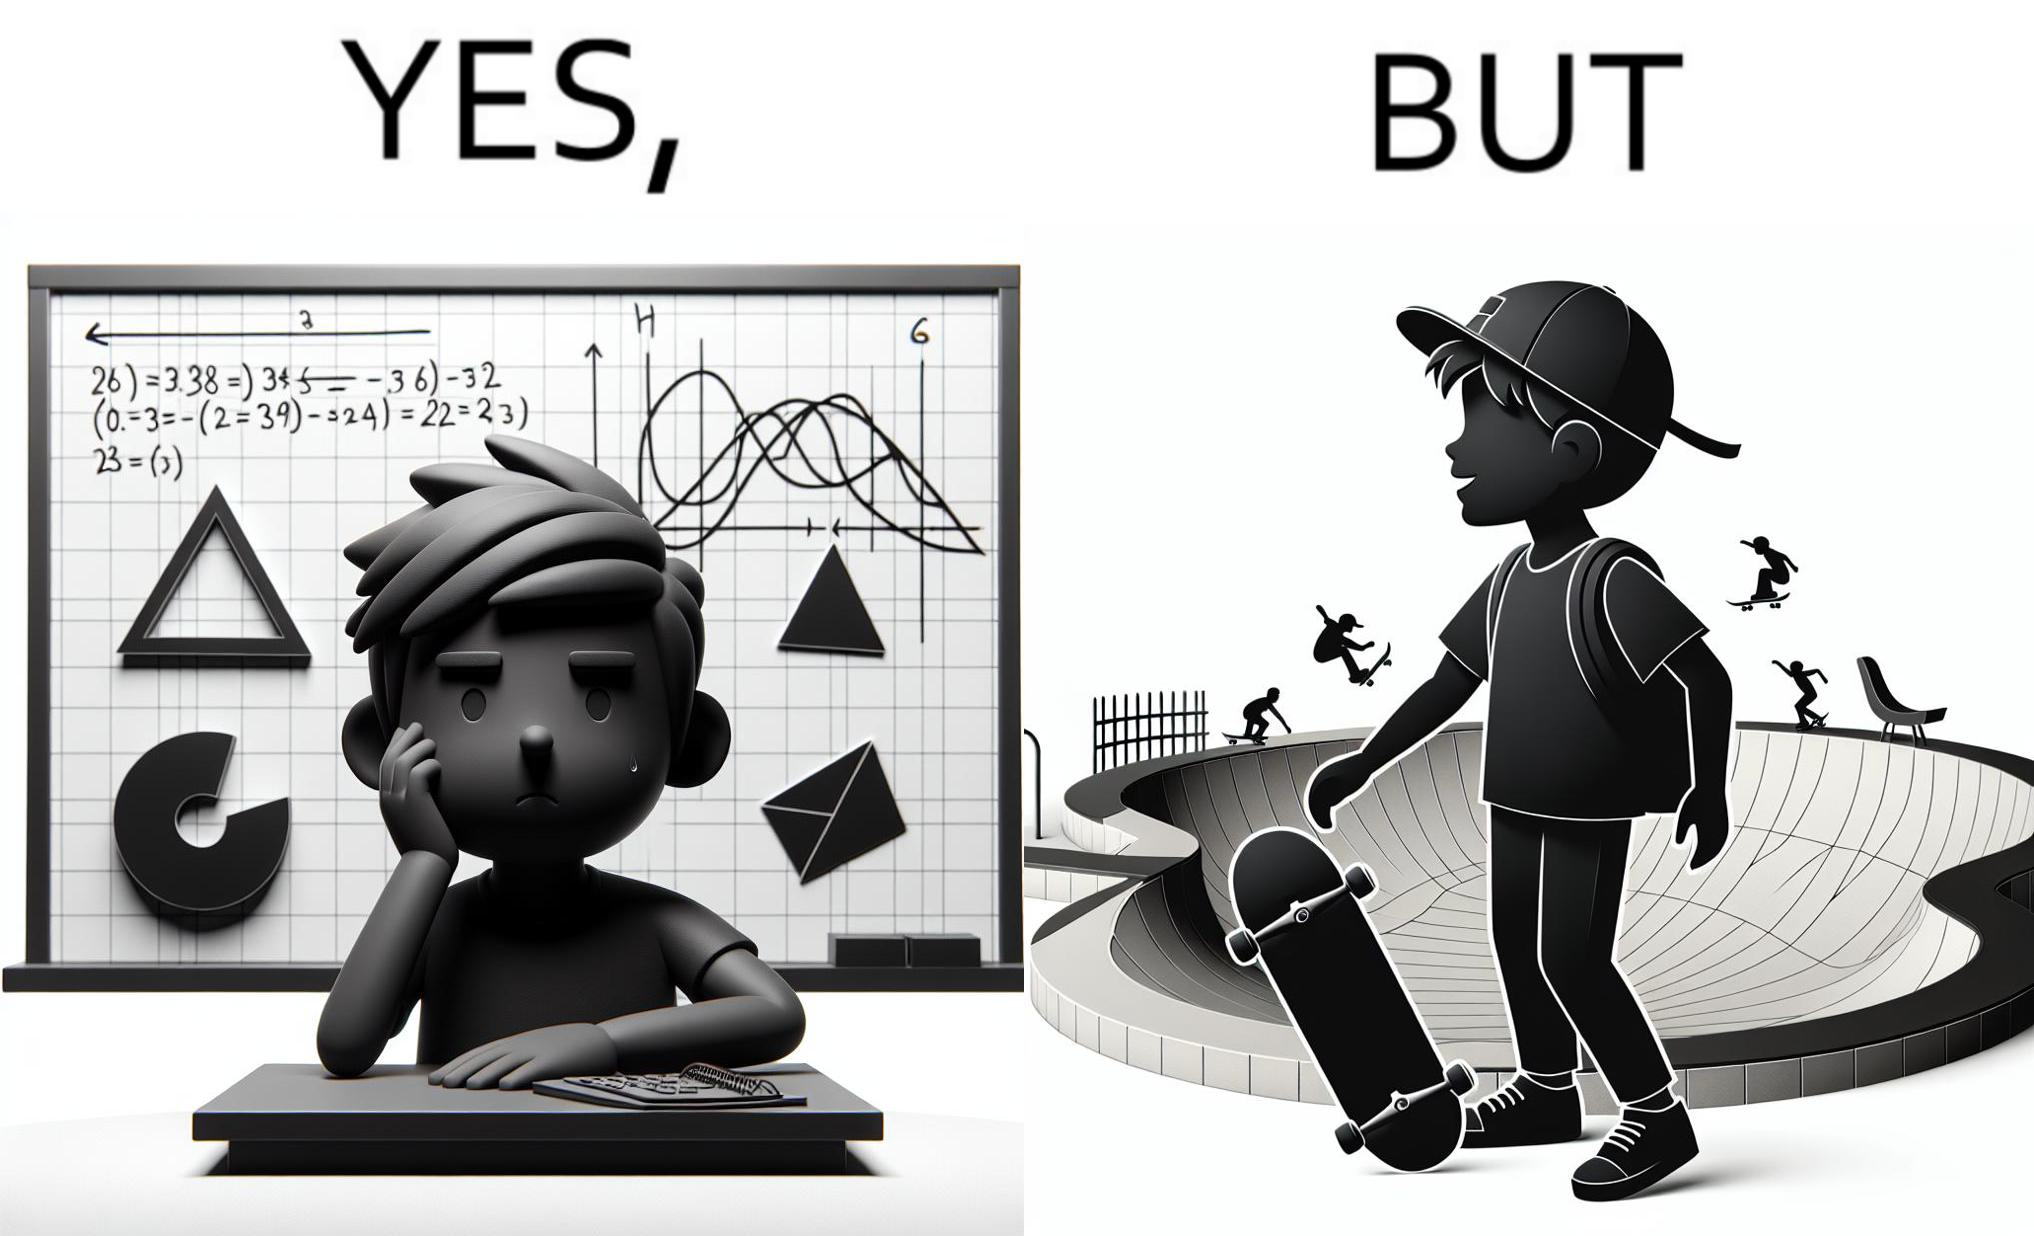Explain the humor or irony in this image. The image is ironical beaucse while the boy does not enjoy studying mathematics and different geometric shapes like semi circle and trapezoid and graphs of trigonometric equations like that of a sine wave, he enjoys skateboarding on surfaces and bowls that are built based on the said geometric shapes and graphs of trigonometric equations. 